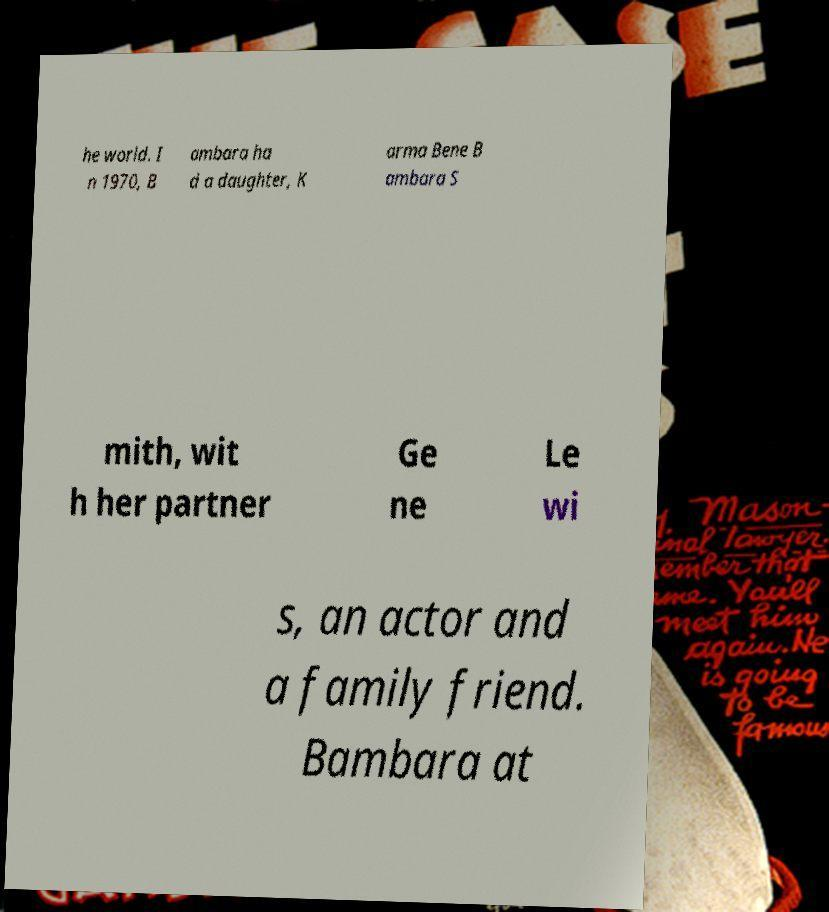Please identify and transcribe the text found in this image. he world. I n 1970, B ambara ha d a daughter, K arma Bene B ambara S mith, wit h her partner Ge ne Le wi s, an actor and a family friend. Bambara at 